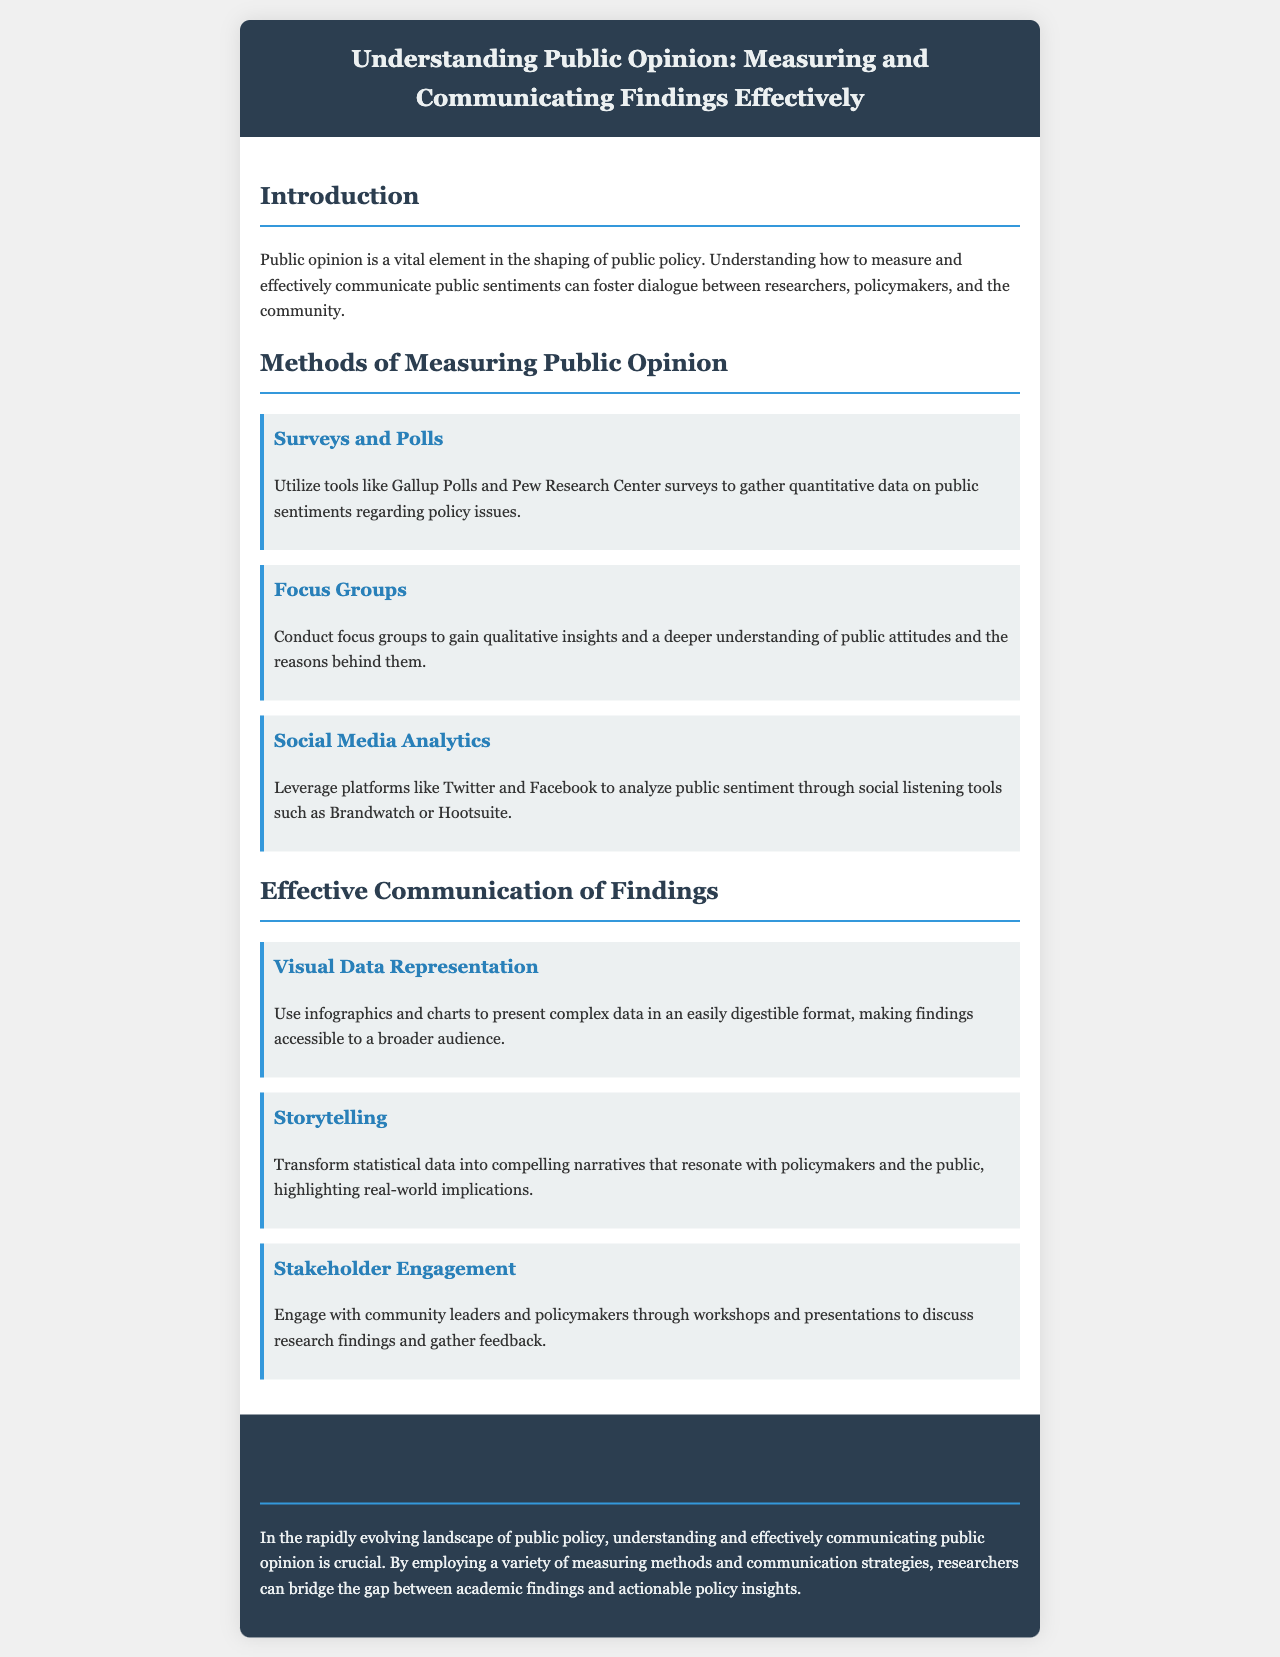What are the methods of measuring public opinion? The methods outlined in the document include surveys and polls, focus groups, and social media analytics.
Answer: Surveys and Polls, Focus Groups, Social Media Analytics Which organization's surveys are mentioned for quantitative data? The document specifically mentions Gallup Polls and Pew Research Center surveys for gathering data.
Answer: Gallup Polls and Pew Research Center What is one strategy for effective communication of findings? The document lists visual data representation, storytelling, and stakeholder engagement as strategies for communication.
Answer: Visual Data Representation What type of insights can focus groups provide? According to the document, focus groups offer qualitative insights and a deeper understanding of public attitudes and their reasons.
Answer: Qualitative insights In which section does the conclusion appear? The conclusion section appears at the end of the brochure, summarizing the importance of understanding and communicating public opinion.
Answer: Conclusion What is emphasized as crucial for researchers in public policy? The conclusion highlights that understanding and effectively communicating public opinion is crucial for researchers in this field.
Answer: Understanding and effectively communicating public opinion What does the strategy of storytelling aim to do? Storytelling transforms statistical data into narratives that resonate with policymakers and the public, highlighting real-world implications.
Answer: Transform statistical data into compelling narratives What color is used for the header background? The header background color in the brochure is a dark shade identified as #2c3e50.
Answer: #2c3e50 